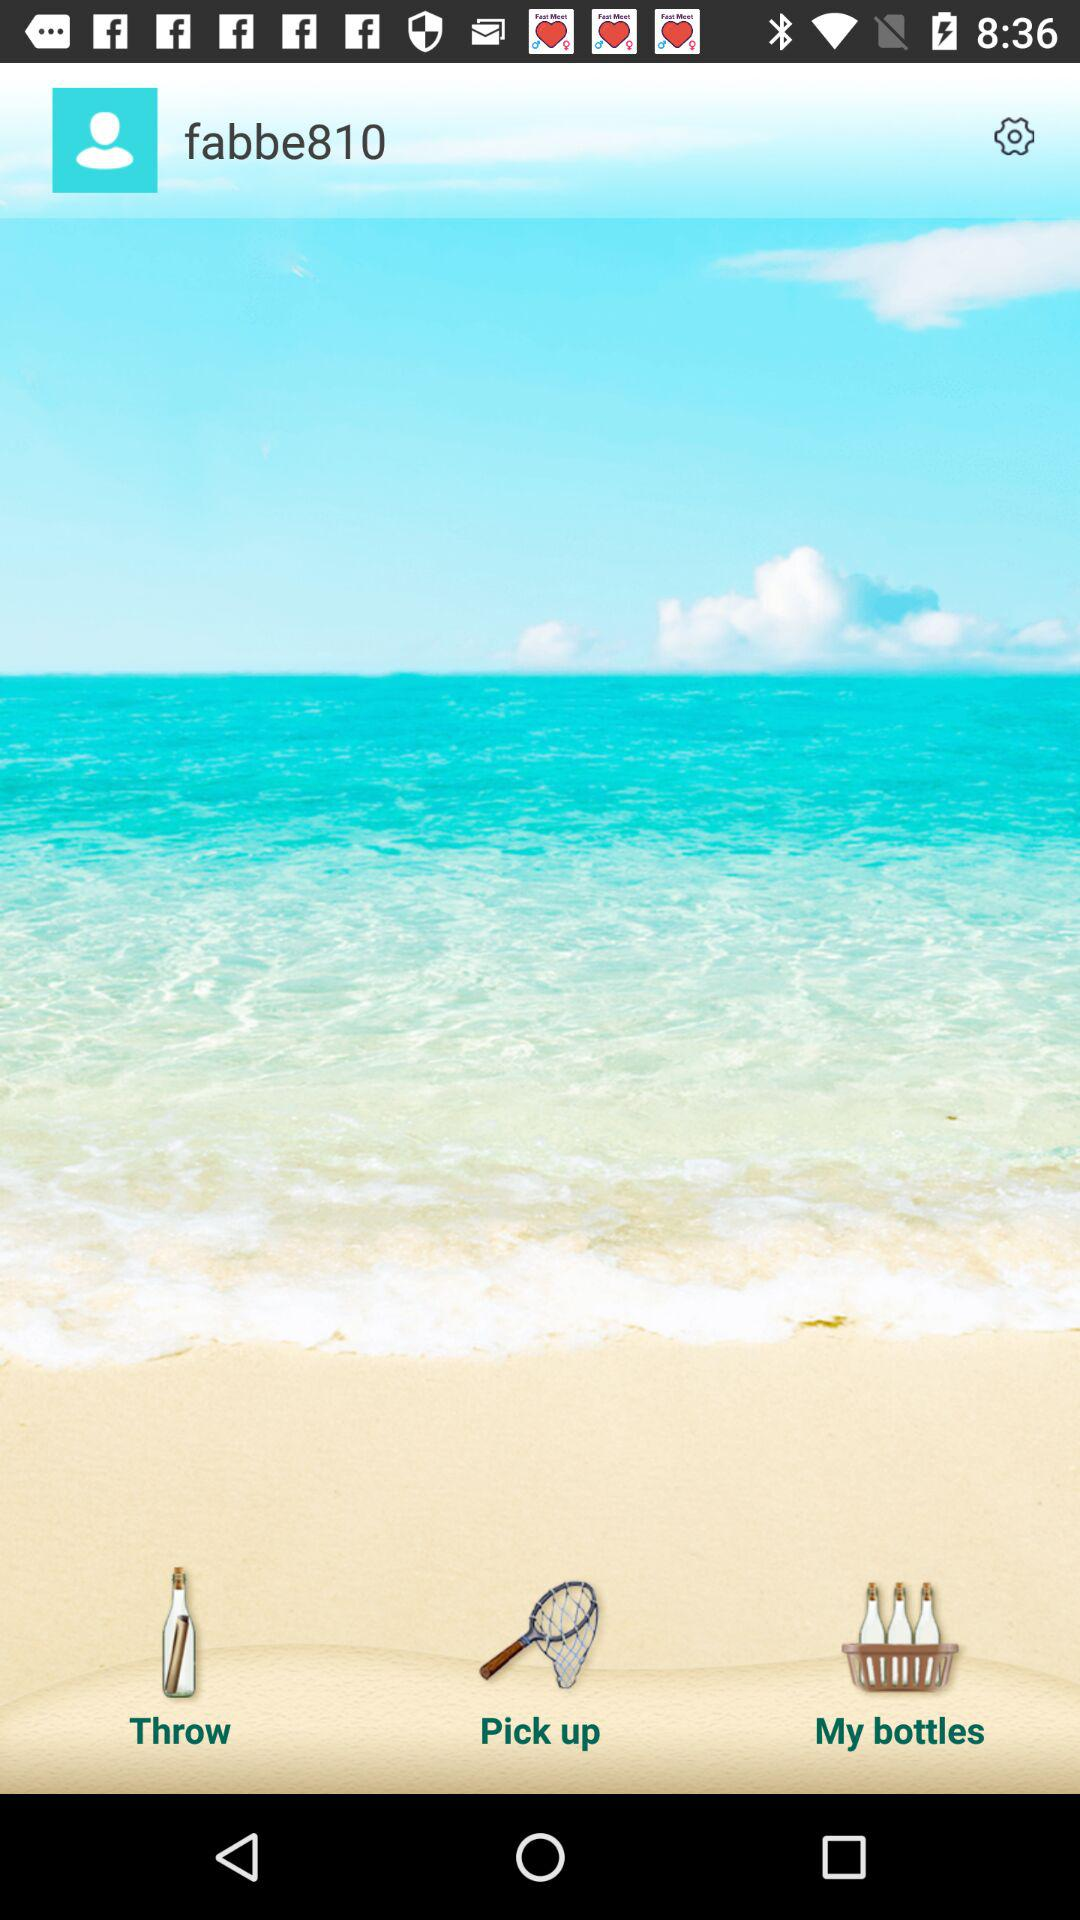What is the username? The username is "fabbe810". 